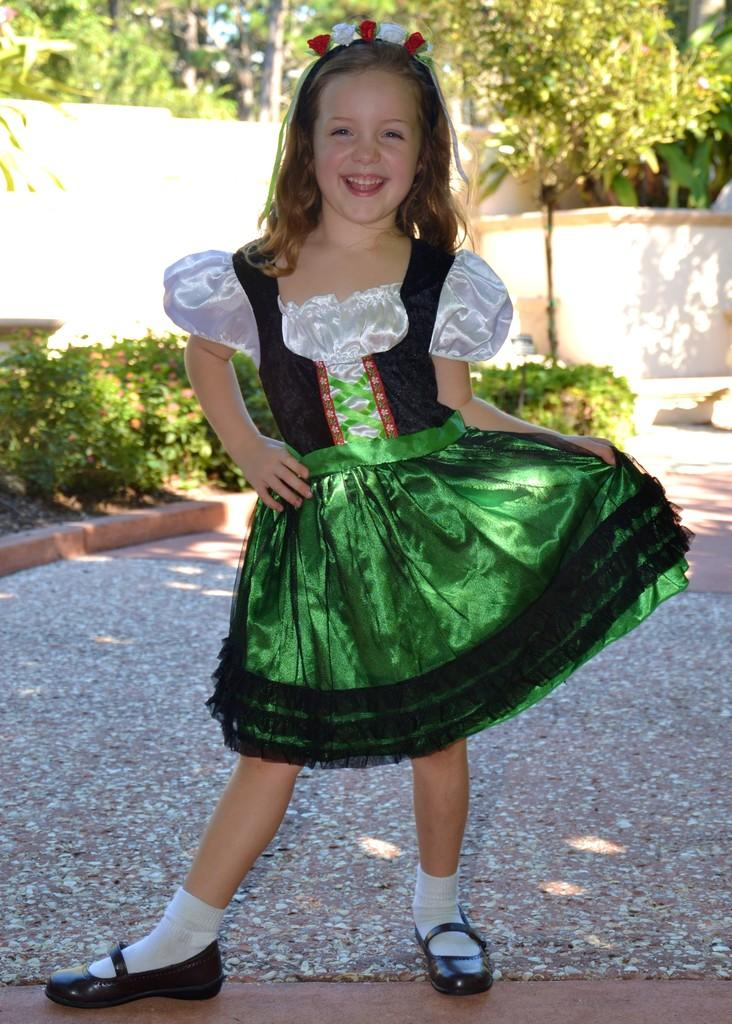What is the main subject of the image? There is a person standing in the image. Can you describe the person's clothing? The person is wearing a dress with green, black, and white colors. What type of footwear is the person wearing? The person is wearing black shoes. What can be seen in the background of the image? There are trees and a wall in the background of the image. What type of flesh can be seen on the person's face in the image? There is no flesh visible on the person's face in the image, as the person is wearing a dress and shoes, but no mention of their face or any exposed skin. 